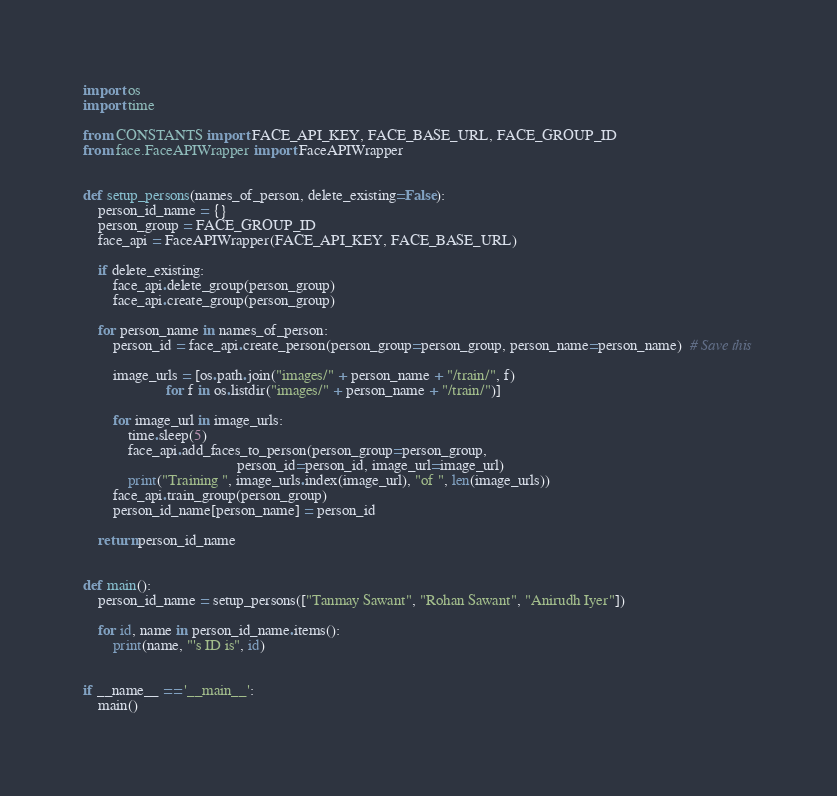<code> <loc_0><loc_0><loc_500><loc_500><_Python_>import os
import time

from CONSTANTS import FACE_API_KEY, FACE_BASE_URL, FACE_GROUP_ID
from face.FaceAPIWrapper import FaceAPIWrapper


def setup_persons(names_of_person, delete_existing=False):
    person_id_name = {}
    person_group = FACE_GROUP_ID
    face_api = FaceAPIWrapper(FACE_API_KEY, FACE_BASE_URL)

    if delete_existing:
        face_api.delete_group(person_group)
        face_api.create_group(person_group)

    for person_name in names_of_person:
        person_id = face_api.create_person(person_group=person_group, person_name=person_name)  # Save this

        image_urls = [os.path.join("images/" + person_name + "/train/", f)
                      for f in os.listdir("images/" + person_name + "/train/")]

        for image_url in image_urls:
            time.sleep(5)
            face_api.add_faces_to_person(person_group=person_group,
                                         person_id=person_id, image_url=image_url)
            print("Training ", image_urls.index(image_url), "of ", len(image_urls))
        face_api.train_group(person_group)
        person_id_name[person_name] = person_id

    return person_id_name


def main():
    person_id_name = setup_persons(["Tanmay Sawant", "Rohan Sawant", "Anirudh Iyer"])

    for id, name in person_id_name.items():
        print(name, "'s ID is", id)


if __name__ == '__main__':
    main()
</code> 